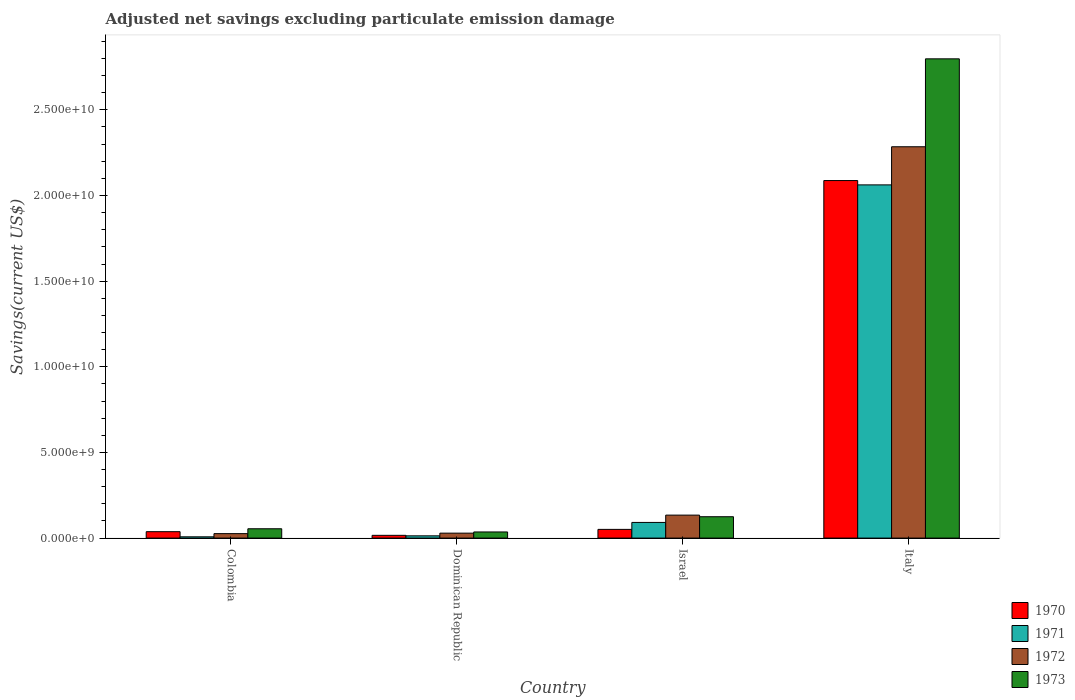How many different coloured bars are there?
Your answer should be very brief. 4. How many groups of bars are there?
Offer a very short reply. 4. Are the number of bars per tick equal to the number of legend labels?
Offer a terse response. Yes. Are the number of bars on each tick of the X-axis equal?
Offer a very short reply. Yes. How many bars are there on the 2nd tick from the left?
Your answer should be compact. 4. How many bars are there on the 2nd tick from the right?
Your response must be concise. 4. What is the label of the 1st group of bars from the left?
Ensure brevity in your answer.  Colombia. In how many cases, is the number of bars for a given country not equal to the number of legend labels?
Your answer should be very brief. 0. What is the adjusted net savings in 1970 in Italy?
Provide a short and direct response. 2.09e+1. Across all countries, what is the maximum adjusted net savings in 1973?
Your response must be concise. 2.80e+1. Across all countries, what is the minimum adjusted net savings in 1973?
Make the answer very short. 3.58e+08. In which country was the adjusted net savings in 1971 maximum?
Your answer should be compact. Italy. What is the total adjusted net savings in 1971 in the graph?
Your answer should be compact. 2.17e+1. What is the difference between the adjusted net savings in 1970 in Israel and that in Italy?
Provide a short and direct response. -2.04e+1. What is the difference between the adjusted net savings in 1973 in Colombia and the adjusted net savings in 1971 in Dominican Republic?
Provide a short and direct response. 4.13e+08. What is the average adjusted net savings in 1971 per country?
Your answer should be compact. 5.43e+09. What is the difference between the adjusted net savings of/in 1972 and adjusted net savings of/in 1973 in Dominican Republic?
Your answer should be compact. -6.95e+07. What is the ratio of the adjusted net savings in 1972 in Dominican Republic to that in Italy?
Your answer should be compact. 0.01. Is the difference between the adjusted net savings in 1972 in Dominican Republic and Italy greater than the difference between the adjusted net savings in 1973 in Dominican Republic and Italy?
Provide a short and direct response. Yes. What is the difference between the highest and the second highest adjusted net savings in 1970?
Provide a short and direct response. 2.05e+1. What is the difference between the highest and the lowest adjusted net savings in 1970?
Provide a succinct answer. 2.07e+1. In how many countries, is the adjusted net savings in 1970 greater than the average adjusted net savings in 1970 taken over all countries?
Make the answer very short. 1. What does the 1st bar from the left in Colombia represents?
Your response must be concise. 1970. What does the 3rd bar from the right in Italy represents?
Make the answer very short. 1971. Are all the bars in the graph horizontal?
Your answer should be very brief. No. How many countries are there in the graph?
Provide a short and direct response. 4. What is the difference between two consecutive major ticks on the Y-axis?
Your answer should be compact. 5.00e+09. Are the values on the major ticks of Y-axis written in scientific E-notation?
Provide a succinct answer. Yes. Does the graph contain grids?
Provide a succinct answer. No. Where does the legend appear in the graph?
Ensure brevity in your answer.  Bottom right. How many legend labels are there?
Give a very brief answer. 4. How are the legend labels stacked?
Give a very brief answer. Vertical. What is the title of the graph?
Ensure brevity in your answer.  Adjusted net savings excluding particulate emission damage. What is the label or title of the Y-axis?
Give a very brief answer. Savings(current US$). What is the Savings(current US$) of 1970 in Colombia?
Make the answer very short. 3.74e+08. What is the Savings(current US$) of 1971 in Colombia?
Keep it short and to the point. 7.46e+07. What is the Savings(current US$) in 1972 in Colombia?
Keep it short and to the point. 2.60e+08. What is the Savings(current US$) in 1973 in Colombia?
Provide a short and direct response. 5.45e+08. What is the Savings(current US$) of 1970 in Dominican Republic?
Ensure brevity in your answer.  1.61e+08. What is the Savings(current US$) in 1971 in Dominican Republic?
Provide a succinct answer. 1.32e+08. What is the Savings(current US$) in 1972 in Dominican Republic?
Keep it short and to the point. 2.89e+08. What is the Savings(current US$) of 1973 in Dominican Republic?
Offer a terse response. 3.58e+08. What is the Savings(current US$) in 1970 in Israel?
Provide a short and direct response. 5.08e+08. What is the Savings(current US$) of 1971 in Israel?
Your answer should be very brief. 9.14e+08. What is the Savings(current US$) of 1972 in Israel?
Make the answer very short. 1.34e+09. What is the Savings(current US$) in 1973 in Israel?
Your response must be concise. 1.25e+09. What is the Savings(current US$) in 1970 in Italy?
Offer a terse response. 2.09e+1. What is the Savings(current US$) of 1971 in Italy?
Your response must be concise. 2.06e+1. What is the Savings(current US$) in 1972 in Italy?
Keep it short and to the point. 2.28e+1. What is the Savings(current US$) in 1973 in Italy?
Your response must be concise. 2.80e+1. Across all countries, what is the maximum Savings(current US$) in 1970?
Ensure brevity in your answer.  2.09e+1. Across all countries, what is the maximum Savings(current US$) in 1971?
Offer a terse response. 2.06e+1. Across all countries, what is the maximum Savings(current US$) of 1972?
Offer a terse response. 2.28e+1. Across all countries, what is the maximum Savings(current US$) in 1973?
Offer a terse response. 2.80e+1. Across all countries, what is the minimum Savings(current US$) of 1970?
Your response must be concise. 1.61e+08. Across all countries, what is the minimum Savings(current US$) in 1971?
Give a very brief answer. 7.46e+07. Across all countries, what is the minimum Savings(current US$) in 1972?
Your answer should be very brief. 2.60e+08. Across all countries, what is the minimum Savings(current US$) in 1973?
Keep it short and to the point. 3.58e+08. What is the total Savings(current US$) in 1970 in the graph?
Your response must be concise. 2.19e+1. What is the total Savings(current US$) in 1971 in the graph?
Ensure brevity in your answer.  2.17e+1. What is the total Savings(current US$) in 1972 in the graph?
Offer a very short reply. 2.47e+1. What is the total Savings(current US$) in 1973 in the graph?
Your answer should be compact. 3.01e+1. What is the difference between the Savings(current US$) of 1970 in Colombia and that in Dominican Republic?
Your response must be concise. 2.13e+08. What is the difference between the Savings(current US$) in 1971 in Colombia and that in Dominican Republic?
Provide a short and direct response. -5.69e+07. What is the difference between the Savings(current US$) of 1972 in Colombia and that in Dominican Republic?
Ensure brevity in your answer.  -2.84e+07. What is the difference between the Savings(current US$) in 1973 in Colombia and that in Dominican Republic?
Give a very brief answer. 1.87e+08. What is the difference between the Savings(current US$) of 1970 in Colombia and that in Israel?
Your answer should be very brief. -1.34e+08. What is the difference between the Savings(current US$) in 1971 in Colombia and that in Israel?
Your answer should be compact. -8.40e+08. What is the difference between the Savings(current US$) of 1972 in Colombia and that in Israel?
Ensure brevity in your answer.  -1.08e+09. What is the difference between the Savings(current US$) of 1973 in Colombia and that in Israel?
Offer a terse response. -7.02e+08. What is the difference between the Savings(current US$) in 1970 in Colombia and that in Italy?
Make the answer very short. -2.05e+1. What is the difference between the Savings(current US$) in 1971 in Colombia and that in Italy?
Ensure brevity in your answer.  -2.05e+1. What is the difference between the Savings(current US$) of 1972 in Colombia and that in Italy?
Your response must be concise. -2.26e+1. What is the difference between the Savings(current US$) in 1973 in Colombia and that in Italy?
Your answer should be very brief. -2.74e+1. What is the difference between the Savings(current US$) of 1970 in Dominican Republic and that in Israel?
Provide a short and direct response. -3.47e+08. What is the difference between the Savings(current US$) in 1971 in Dominican Republic and that in Israel?
Your answer should be very brief. -7.83e+08. What is the difference between the Savings(current US$) of 1972 in Dominican Republic and that in Israel?
Ensure brevity in your answer.  -1.05e+09. What is the difference between the Savings(current US$) in 1973 in Dominican Republic and that in Israel?
Make the answer very short. -8.89e+08. What is the difference between the Savings(current US$) of 1970 in Dominican Republic and that in Italy?
Provide a succinct answer. -2.07e+1. What is the difference between the Savings(current US$) of 1971 in Dominican Republic and that in Italy?
Offer a very short reply. -2.05e+1. What is the difference between the Savings(current US$) of 1972 in Dominican Republic and that in Italy?
Ensure brevity in your answer.  -2.26e+1. What is the difference between the Savings(current US$) of 1973 in Dominican Republic and that in Italy?
Provide a short and direct response. -2.76e+1. What is the difference between the Savings(current US$) of 1970 in Israel and that in Italy?
Ensure brevity in your answer.  -2.04e+1. What is the difference between the Savings(current US$) in 1971 in Israel and that in Italy?
Provide a short and direct response. -1.97e+1. What is the difference between the Savings(current US$) in 1972 in Israel and that in Italy?
Provide a succinct answer. -2.15e+1. What is the difference between the Savings(current US$) in 1973 in Israel and that in Italy?
Provide a succinct answer. -2.67e+1. What is the difference between the Savings(current US$) of 1970 in Colombia and the Savings(current US$) of 1971 in Dominican Republic?
Your answer should be compact. 2.42e+08. What is the difference between the Savings(current US$) in 1970 in Colombia and the Savings(current US$) in 1972 in Dominican Republic?
Offer a very short reply. 8.52e+07. What is the difference between the Savings(current US$) of 1970 in Colombia and the Savings(current US$) of 1973 in Dominican Republic?
Keep it short and to the point. 1.57e+07. What is the difference between the Savings(current US$) in 1971 in Colombia and the Savings(current US$) in 1972 in Dominican Republic?
Ensure brevity in your answer.  -2.14e+08. What is the difference between the Savings(current US$) of 1971 in Colombia and the Savings(current US$) of 1973 in Dominican Republic?
Your answer should be very brief. -2.84e+08. What is the difference between the Savings(current US$) in 1972 in Colombia and the Savings(current US$) in 1973 in Dominican Republic?
Provide a succinct answer. -9.79e+07. What is the difference between the Savings(current US$) of 1970 in Colombia and the Savings(current US$) of 1971 in Israel?
Provide a short and direct response. -5.40e+08. What is the difference between the Savings(current US$) in 1970 in Colombia and the Savings(current US$) in 1972 in Israel?
Provide a short and direct response. -9.67e+08. What is the difference between the Savings(current US$) in 1970 in Colombia and the Savings(current US$) in 1973 in Israel?
Provide a short and direct response. -8.73e+08. What is the difference between the Savings(current US$) in 1971 in Colombia and the Savings(current US$) in 1972 in Israel?
Your response must be concise. -1.27e+09. What is the difference between the Savings(current US$) of 1971 in Colombia and the Savings(current US$) of 1973 in Israel?
Ensure brevity in your answer.  -1.17e+09. What is the difference between the Savings(current US$) of 1972 in Colombia and the Savings(current US$) of 1973 in Israel?
Provide a succinct answer. -9.87e+08. What is the difference between the Savings(current US$) in 1970 in Colombia and the Savings(current US$) in 1971 in Italy?
Give a very brief answer. -2.02e+1. What is the difference between the Savings(current US$) in 1970 in Colombia and the Savings(current US$) in 1972 in Italy?
Your answer should be compact. -2.25e+1. What is the difference between the Savings(current US$) of 1970 in Colombia and the Savings(current US$) of 1973 in Italy?
Offer a terse response. -2.76e+1. What is the difference between the Savings(current US$) of 1971 in Colombia and the Savings(current US$) of 1972 in Italy?
Offer a terse response. -2.28e+1. What is the difference between the Savings(current US$) of 1971 in Colombia and the Savings(current US$) of 1973 in Italy?
Your answer should be compact. -2.79e+1. What is the difference between the Savings(current US$) of 1972 in Colombia and the Savings(current US$) of 1973 in Italy?
Keep it short and to the point. -2.77e+1. What is the difference between the Savings(current US$) of 1970 in Dominican Republic and the Savings(current US$) of 1971 in Israel?
Provide a succinct answer. -7.53e+08. What is the difference between the Savings(current US$) in 1970 in Dominican Republic and the Savings(current US$) in 1972 in Israel?
Provide a short and direct response. -1.18e+09. What is the difference between the Savings(current US$) in 1970 in Dominican Republic and the Savings(current US$) in 1973 in Israel?
Offer a very short reply. -1.09e+09. What is the difference between the Savings(current US$) in 1971 in Dominican Republic and the Savings(current US$) in 1972 in Israel?
Your response must be concise. -1.21e+09. What is the difference between the Savings(current US$) of 1971 in Dominican Republic and the Savings(current US$) of 1973 in Israel?
Make the answer very short. -1.12e+09. What is the difference between the Savings(current US$) of 1972 in Dominican Republic and the Savings(current US$) of 1973 in Israel?
Your answer should be very brief. -9.58e+08. What is the difference between the Savings(current US$) in 1970 in Dominican Republic and the Savings(current US$) in 1971 in Italy?
Make the answer very short. -2.05e+1. What is the difference between the Savings(current US$) of 1970 in Dominican Republic and the Savings(current US$) of 1972 in Italy?
Provide a succinct answer. -2.27e+1. What is the difference between the Savings(current US$) in 1970 in Dominican Republic and the Savings(current US$) in 1973 in Italy?
Keep it short and to the point. -2.78e+1. What is the difference between the Savings(current US$) of 1971 in Dominican Republic and the Savings(current US$) of 1972 in Italy?
Ensure brevity in your answer.  -2.27e+1. What is the difference between the Savings(current US$) of 1971 in Dominican Republic and the Savings(current US$) of 1973 in Italy?
Your response must be concise. -2.78e+1. What is the difference between the Savings(current US$) in 1972 in Dominican Republic and the Savings(current US$) in 1973 in Italy?
Provide a succinct answer. -2.77e+1. What is the difference between the Savings(current US$) of 1970 in Israel and the Savings(current US$) of 1971 in Italy?
Offer a very short reply. -2.01e+1. What is the difference between the Savings(current US$) of 1970 in Israel and the Savings(current US$) of 1972 in Italy?
Your response must be concise. -2.23e+1. What is the difference between the Savings(current US$) in 1970 in Israel and the Savings(current US$) in 1973 in Italy?
Your answer should be very brief. -2.75e+1. What is the difference between the Savings(current US$) in 1971 in Israel and the Savings(current US$) in 1972 in Italy?
Offer a very short reply. -2.19e+1. What is the difference between the Savings(current US$) in 1971 in Israel and the Savings(current US$) in 1973 in Italy?
Offer a terse response. -2.71e+1. What is the difference between the Savings(current US$) in 1972 in Israel and the Savings(current US$) in 1973 in Italy?
Your answer should be very brief. -2.66e+1. What is the average Savings(current US$) of 1970 per country?
Provide a succinct answer. 5.48e+09. What is the average Savings(current US$) in 1971 per country?
Make the answer very short. 5.43e+09. What is the average Savings(current US$) in 1972 per country?
Ensure brevity in your answer.  6.18e+09. What is the average Savings(current US$) in 1973 per country?
Offer a terse response. 7.53e+09. What is the difference between the Savings(current US$) of 1970 and Savings(current US$) of 1971 in Colombia?
Make the answer very short. 2.99e+08. What is the difference between the Savings(current US$) of 1970 and Savings(current US$) of 1972 in Colombia?
Provide a short and direct response. 1.14e+08. What is the difference between the Savings(current US$) of 1970 and Savings(current US$) of 1973 in Colombia?
Your answer should be compact. -1.71e+08. What is the difference between the Savings(current US$) of 1971 and Savings(current US$) of 1972 in Colombia?
Keep it short and to the point. -1.86e+08. What is the difference between the Savings(current US$) in 1971 and Savings(current US$) in 1973 in Colombia?
Your answer should be compact. -4.70e+08. What is the difference between the Savings(current US$) in 1972 and Savings(current US$) in 1973 in Colombia?
Your answer should be very brief. -2.85e+08. What is the difference between the Savings(current US$) of 1970 and Savings(current US$) of 1971 in Dominican Republic?
Keep it short and to the point. 2.96e+07. What is the difference between the Savings(current US$) of 1970 and Savings(current US$) of 1972 in Dominican Republic?
Give a very brief answer. -1.28e+08. What is the difference between the Savings(current US$) in 1970 and Savings(current US$) in 1973 in Dominican Republic?
Provide a short and direct response. -1.97e+08. What is the difference between the Savings(current US$) in 1971 and Savings(current US$) in 1972 in Dominican Republic?
Provide a short and direct response. -1.57e+08. What is the difference between the Savings(current US$) in 1971 and Savings(current US$) in 1973 in Dominican Republic?
Your answer should be compact. -2.27e+08. What is the difference between the Savings(current US$) in 1972 and Savings(current US$) in 1973 in Dominican Republic?
Offer a terse response. -6.95e+07. What is the difference between the Savings(current US$) in 1970 and Savings(current US$) in 1971 in Israel?
Give a very brief answer. -4.06e+08. What is the difference between the Savings(current US$) of 1970 and Savings(current US$) of 1972 in Israel?
Your answer should be compact. -8.33e+08. What is the difference between the Savings(current US$) in 1970 and Savings(current US$) in 1973 in Israel?
Give a very brief answer. -7.39e+08. What is the difference between the Savings(current US$) of 1971 and Savings(current US$) of 1972 in Israel?
Offer a very short reply. -4.27e+08. What is the difference between the Savings(current US$) in 1971 and Savings(current US$) in 1973 in Israel?
Offer a very short reply. -3.33e+08. What is the difference between the Savings(current US$) in 1972 and Savings(current US$) in 1973 in Israel?
Provide a short and direct response. 9.40e+07. What is the difference between the Savings(current US$) in 1970 and Savings(current US$) in 1971 in Italy?
Give a very brief answer. 2.53e+08. What is the difference between the Savings(current US$) of 1970 and Savings(current US$) of 1972 in Italy?
Ensure brevity in your answer.  -1.97e+09. What is the difference between the Savings(current US$) in 1970 and Savings(current US$) in 1973 in Italy?
Your response must be concise. -7.11e+09. What is the difference between the Savings(current US$) in 1971 and Savings(current US$) in 1972 in Italy?
Your answer should be very brief. -2.23e+09. What is the difference between the Savings(current US$) in 1971 and Savings(current US$) in 1973 in Italy?
Ensure brevity in your answer.  -7.36e+09. What is the difference between the Savings(current US$) of 1972 and Savings(current US$) of 1973 in Italy?
Your answer should be very brief. -5.13e+09. What is the ratio of the Savings(current US$) in 1970 in Colombia to that in Dominican Republic?
Keep it short and to the point. 2.32. What is the ratio of the Savings(current US$) in 1971 in Colombia to that in Dominican Republic?
Your response must be concise. 0.57. What is the ratio of the Savings(current US$) in 1972 in Colombia to that in Dominican Republic?
Offer a terse response. 0.9. What is the ratio of the Savings(current US$) in 1973 in Colombia to that in Dominican Republic?
Keep it short and to the point. 1.52. What is the ratio of the Savings(current US$) of 1970 in Colombia to that in Israel?
Give a very brief answer. 0.74. What is the ratio of the Savings(current US$) in 1971 in Colombia to that in Israel?
Keep it short and to the point. 0.08. What is the ratio of the Savings(current US$) in 1972 in Colombia to that in Israel?
Keep it short and to the point. 0.19. What is the ratio of the Savings(current US$) of 1973 in Colombia to that in Israel?
Offer a very short reply. 0.44. What is the ratio of the Savings(current US$) of 1970 in Colombia to that in Italy?
Your response must be concise. 0.02. What is the ratio of the Savings(current US$) in 1971 in Colombia to that in Italy?
Your answer should be compact. 0. What is the ratio of the Savings(current US$) of 1972 in Colombia to that in Italy?
Keep it short and to the point. 0.01. What is the ratio of the Savings(current US$) in 1973 in Colombia to that in Italy?
Your response must be concise. 0.02. What is the ratio of the Savings(current US$) of 1970 in Dominican Republic to that in Israel?
Keep it short and to the point. 0.32. What is the ratio of the Savings(current US$) in 1971 in Dominican Republic to that in Israel?
Provide a succinct answer. 0.14. What is the ratio of the Savings(current US$) of 1972 in Dominican Republic to that in Israel?
Your answer should be compact. 0.22. What is the ratio of the Savings(current US$) of 1973 in Dominican Republic to that in Israel?
Offer a very short reply. 0.29. What is the ratio of the Savings(current US$) of 1970 in Dominican Republic to that in Italy?
Your answer should be compact. 0.01. What is the ratio of the Savings(current US$) of 1971 in Dominican Republic to that in Italy?
Keep it short and to the point. 0.01. What is the ratio of the Savings(current US$) of 1972 in Dominican Republic to that in Italy?
Provide a succinct answer. 0.01. What is the ratio of the Savings(current US$) in 1973 in Dominican Republic to that in Italy?
Your answer should be compact. 0.01. What is the ratio of the Savings(current US$) of 1970 in Israel to that in Italy?
Offer a terse response. 0.02. What is the ratio of the Savings(current US$) in 1971 in Israel to that in Italy?
Your response must be concise. 0.04. What is the ratio of the Savings(current US$) in 1972 in Israel to that in Italy?
Keep it short and to the point. 0.06. What is the ratio of the Savings(current US$) of 1973 in Israel to that in Italy?
Provide a succinct answer. 0.04. What is the difference between the highest and the second highest Savings(current US$) in 1970?
Your answer should be very brief. 2.04e+1. What is the difference between the highest and the second highest Savings(current US$) in 1971?
Your answer should be very brief. 1.97e+1. What is the difference between the highest and the second highest Savings(current US$) of 1972?
Keep it short and to the point. 2.15e+1. What is the difference between the highest and the second highest Savings(current US$) of 1973?
Ensure brevity in your answer.  2.67e+1. What is the difference between the highest and the lowest Savings(current US$) in 1970?
Ensure brevity in your answer.  2.07e+1. What is the difference between the highest and the lowest Savings(current US$) in 1971?
Offer a terse response. 2.05e+1. What is the difference between the highest and the lowest Savings(current US$) in 1972?
Ensure brevity in your answer.  2.26e+1. What is the difference between the highest and the lowest Savings(current US$) in 1973?
Your response must be concise. 2.76e+1. 